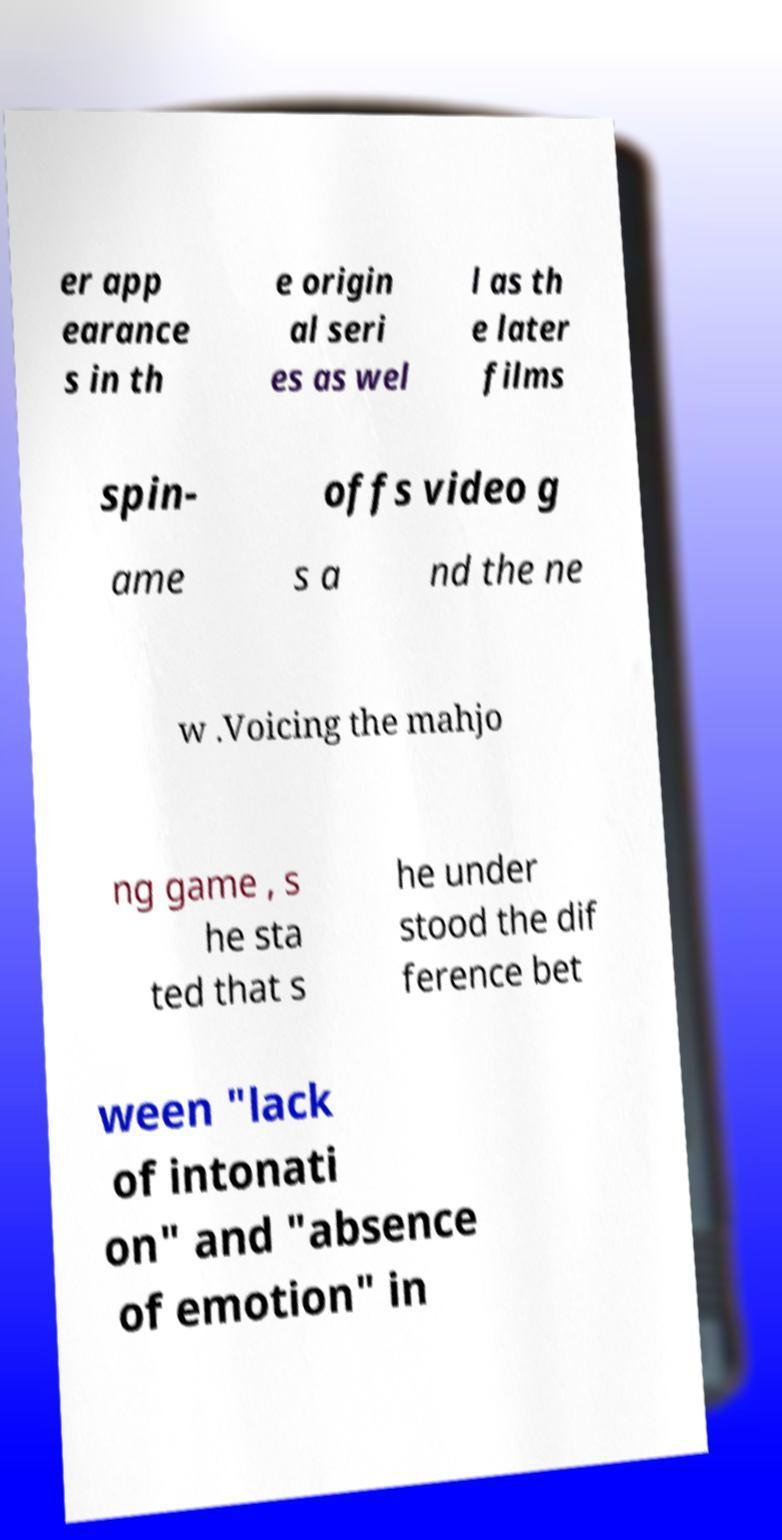Can you read and provide the text displayed in the image?This photo seems to have some interesting text. Can you extract and type it out for me? er app earance s in th e origin al seri es as wel l as th e later films spin- offs video g ame s a nd the ne w .Voicing the mahjo ng game , s he sta ted that s he under stood the dif ference bet ween "lack of intonati on" and "absence of emotion" in 